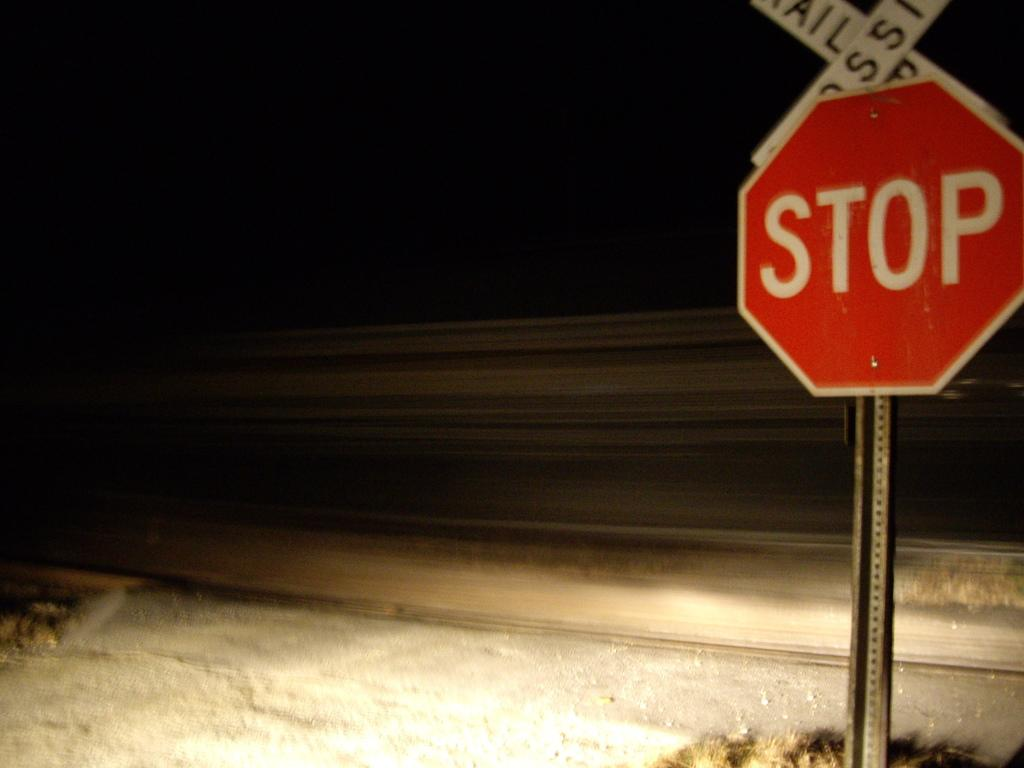Provide a one-sentence caption for the provided image. A railroad crossing sign sits atop a traditional red stop sign. 